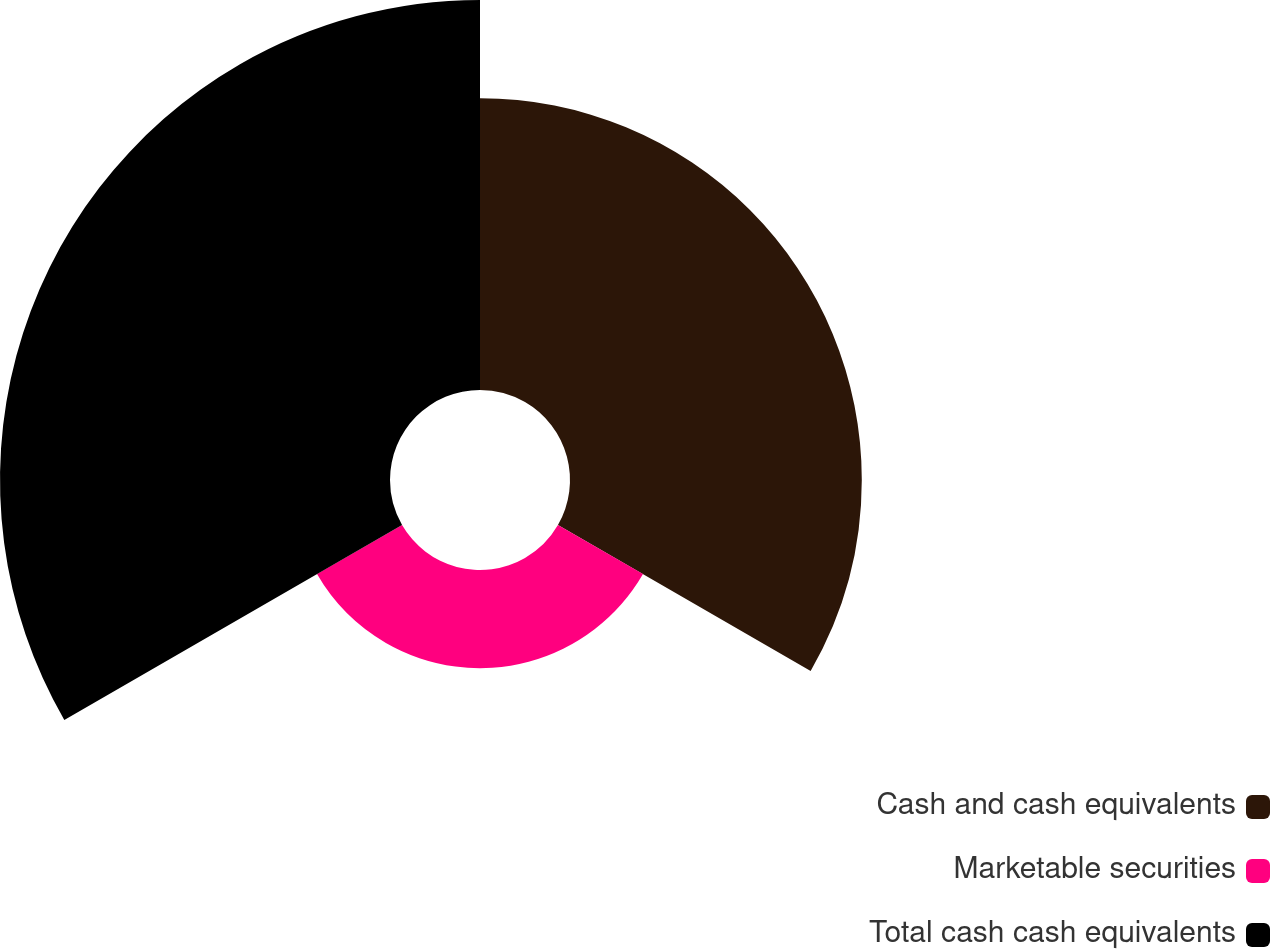Convert chart. <chart><loc_0><loc_0><loc_500><loc_500><pie_chart><fcel>Cash and cash equivalents<fcel>Marketable securities<fcel>Total cash cash equivalents<nl><fcel>37.41%<fcel>12.59%<fcel>50.0%<nl></chart> 